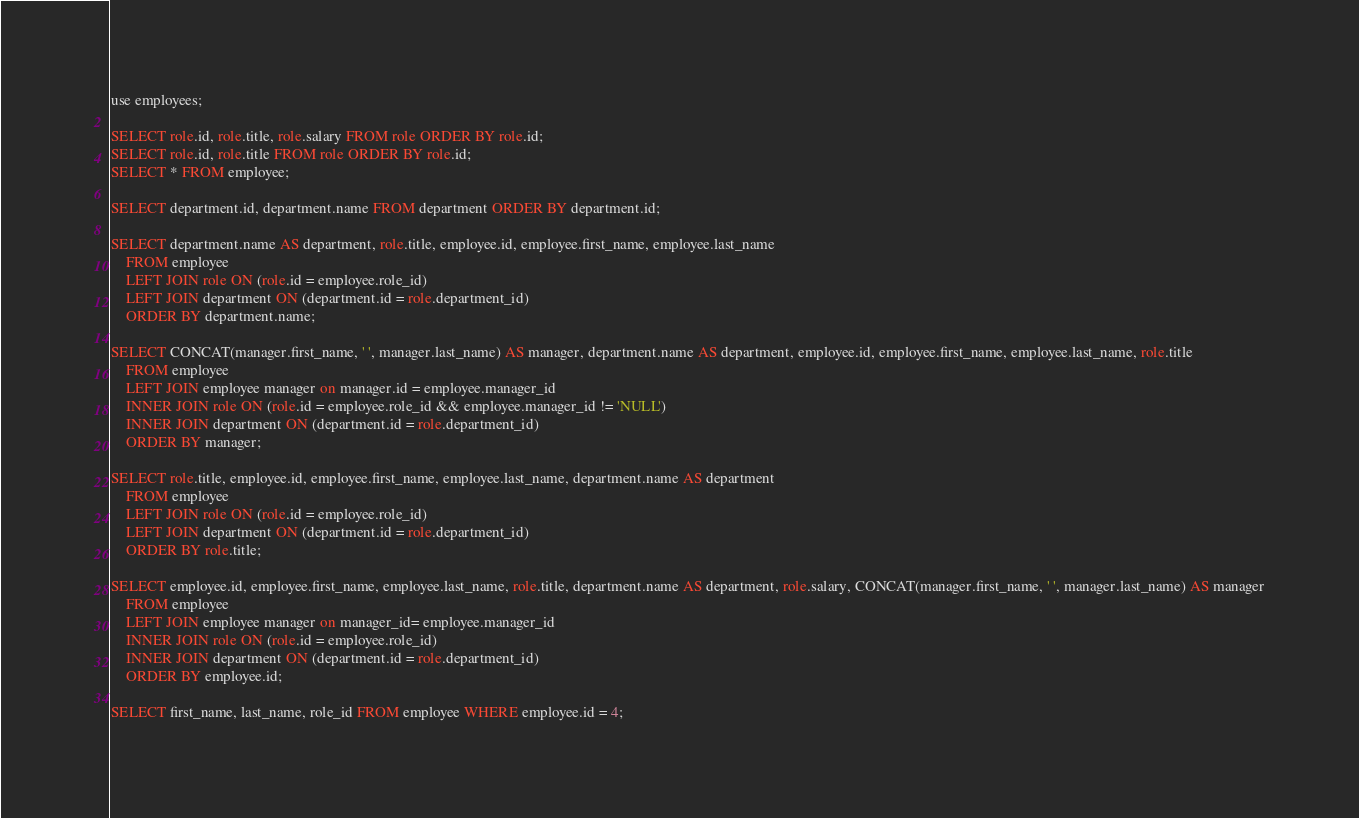<code> <loc_0><loc_0><loc_500><loc_500><_SQL_>use employees;

SELECT role.id, role.title, role.salary FROM role ORDER BY role.id;
SELECT role.id, role.title FROM role ORDER BY role.id;
SELECT * FROM employee;

SELECT department.id, department.name FROM department ORDER BY department.id;

SELECT department.name AS department, role.title, employee.id, employee.first_name, employee.last_name
    FROM employee
    LEFT JOIN role ON (role.id = employee.role_id)
    LEFT JOIN department ON (department.id = role.department_id)
    ORDER BY department.name;

SELECT CONCAT(manager.first_name, ' ', manager.last_name) AS manager, department.name AS department, employee.id, employee.first_name, employee.last_name, role.title
    FROM employee
    LEFT JOIN employee manager on manager.id = employee.manager_id
    INNER JOIN role ON (role.id = employee.role_id && employee.manager_id != 'NULL')
    INNER JOIN department ON (department.id = role.department_id)
    ORDER BY manager;

SELECT role.title, employee.id, employee.first_name, employee.last_name, department.name AS department
    FROM employee
    LEFT JOIN role ON (role.id = employee.role_id)
    LEFT JOIN department ON (department.id = role.department_id)
    ORDER BY role.title;

SELECT employee.id, employee.first_name, employee.last_name, role.title, department.name AS department, role.salary, CONCAT(manager.first_name, ' ', manager.last_name) AS manager
    FROM employee
    LEFT JOIN employee manager on manager_id= employee.manager_id
    INNER JOIN role ON (role.id = employee.role_id)
    INNER JOIN department ON (department.id = role.department_id)
    ORDER BY employee.id;

SELECT first_name, last_name, role_id FROM employee WHERE employee.id = 4;</code> 